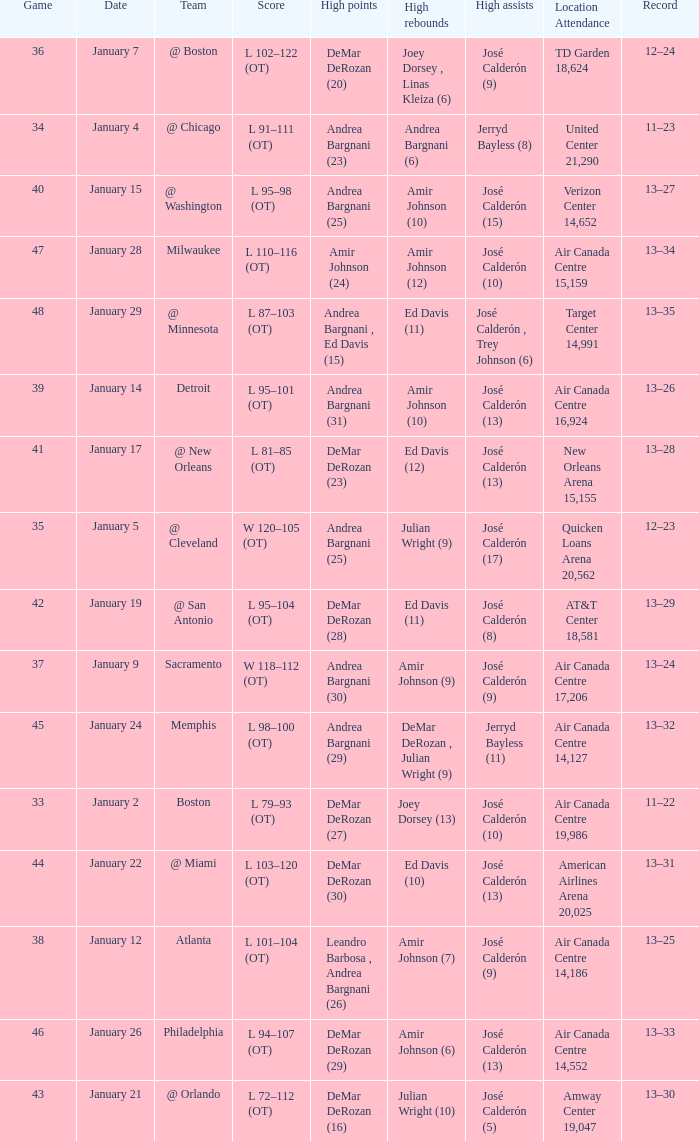Write the full table. {'header': ['Game', 'Date', 'Team', 'Score', 'High points', 'High rebounds', 'High assists', 'Location Attendance', 'Record'], 'rows': [['36', 'January 7', '@ Boston', 'L 102–122 (OT)', 'DeMar DeRozan (20)', 'Joey Dorsey , Linas Kleiza (6)', 'José Calderón (9)', 'TD Garden 18,624', '12–24'], ['34', 'January 4', '@ Chicago', 'L 91–111 (OT)', 'Andrea Bargnani (23)', 'Andrea Bargnani (6)', 'Jerryd Bayless (8)', 'United Center 21,290', '11–23'], ['40', 'January 15', '@ Washington', 'L 95–98 (OT)', 'Andrea Bargnani (25)', 'Amir Johnson (10)', 'José Calderón (15)', 'Verizon Center 14,652', '13–27'], ['47', 'January 28', 'Milwaukee', 'L 110–116 (OT)', 'Amir Johnson (24)', 'Amir Johnson (12)', 'José Calderón (10)', 'Air Canada Centre 15,159', '13–34'], ['48', 'January 29', '@ Minnesota', 'L 87–103 (OT)', 'Andrea Bargnani , Ed Davis (15)', 'Ed Davis (11)', 'José Calderón , Trey Johnson (6)', 'Target Center 14,991', '13–35'], ['39', 'January 14', 'Detroit', 'L 95–101 (OT)', 'Andrea Bargnani (31)', 'Amir Johnson (10)', 'José Calderón (13)', 'Air Canada Centre 16,924', '13–26'], ['41', 'January 17', '@ New Orleans', 'L 81–85 (OT)', 'DeMar DeRozan (23)', 'Ed Davis (12)', 'José Calderón (13)', 'New Orleans Arena 15,155', '13–28'], ['35', 'January 5', '@ Cleveland', 'W 120–105 (OT)', 'Andrea Bargnani (25)', 'Julian Wright (9)', 'José Calderón (17)', 'Quicken Loans Arena 20,562', '12–23'], ['42', 'January 19', '@ San Antonio', 'L 95–104 (OT)', 'DeMar DeRozan (28)', 'Ed Davis (11)', 'José Calderón (8)', 'AT&T Center 18,581', '13–29'], ['37', 'January 9', 'Sacramento', 'W 118–112 (OT)', 'Andrea Bargnani (30)', 'Amir Johnson (9)', 'José Calderón (9)', 'Air Canada Centre 17,206', '13–24'], ['45', 'January 24', 'Memphis', 'L 98–100 (OT)', 'Andrea Bargnani (29)', 'DeMar DeRozan , Julian Wright (9)', 'Jerryd Bayless (11)', 'Air Canada Centre 14,127', '13–32'], ['33', 'January 2', 'Boston', 'L 79–93 (OT)', 'DeMar DeRozan (27)', 'Joey Dorsey (13)', 'José Calderón (10)', 'Air Canada Centre 19,986', '11–22'], ['44', 'January 22', '@ Miami', 'L 103–120 (OT)', 'DeMar DeRozan (30)', 'Ed Davis (10)', 'José Calderón (13)', 'American Airlines Arena 20,025', '13–31'], ['38', 'January 12', 'Atlanta', 'L 101–104 (OT)', 'Leandro Barbosa , Andrea Bargnani (26)', 'Amir Johnson (7)', 'José Calderón (9)', 'Air Canada Centre 14,186', '13–25'], ['46', 'January 26', 'Philadelphia', 'L 94–107 (OT)', 'DeMar DeRozan (29)', 'Amir Johnson (6)', 'José Calderón (13)', 'Air Canada Centre 14,552', '13–33'], ['43', 'January 21', '@ Orlando', 'L 72–112 (OT)', 'DeMar DeRozan (16)', 'Julian Wright (10)', 'José Calderón (5)', 'Amway Center 19,047', '13–30']]} Name the team for january 17 @ New Orleans. 